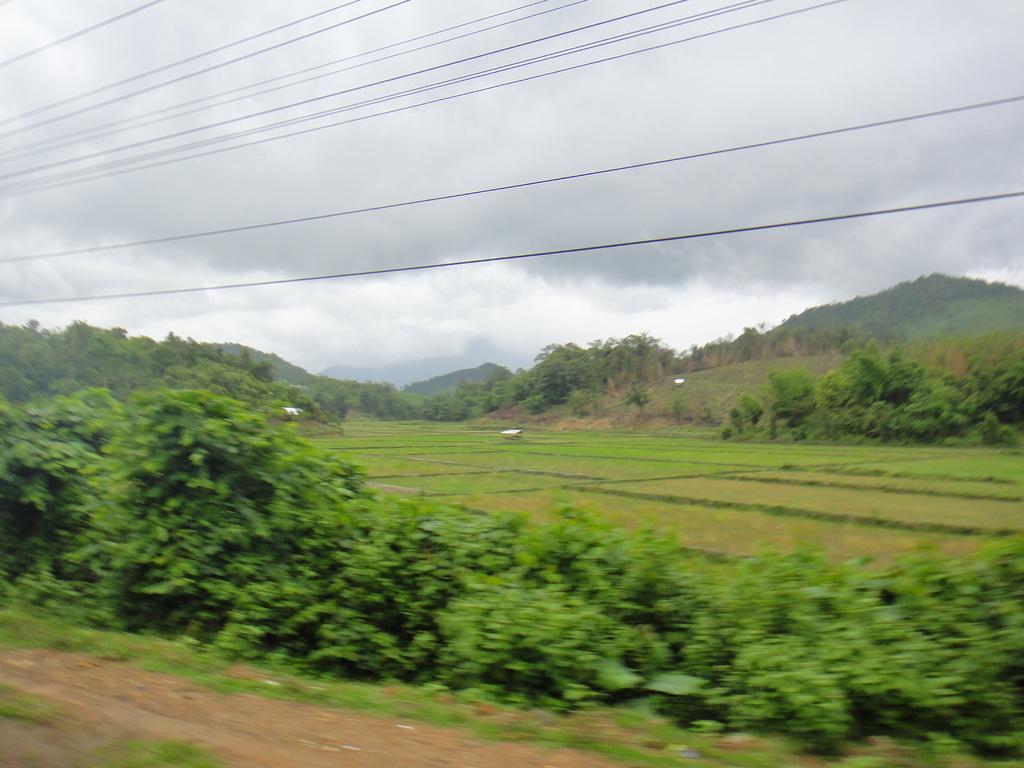Describe this image in one or two sentences. These are trees and cables, this is sky. 